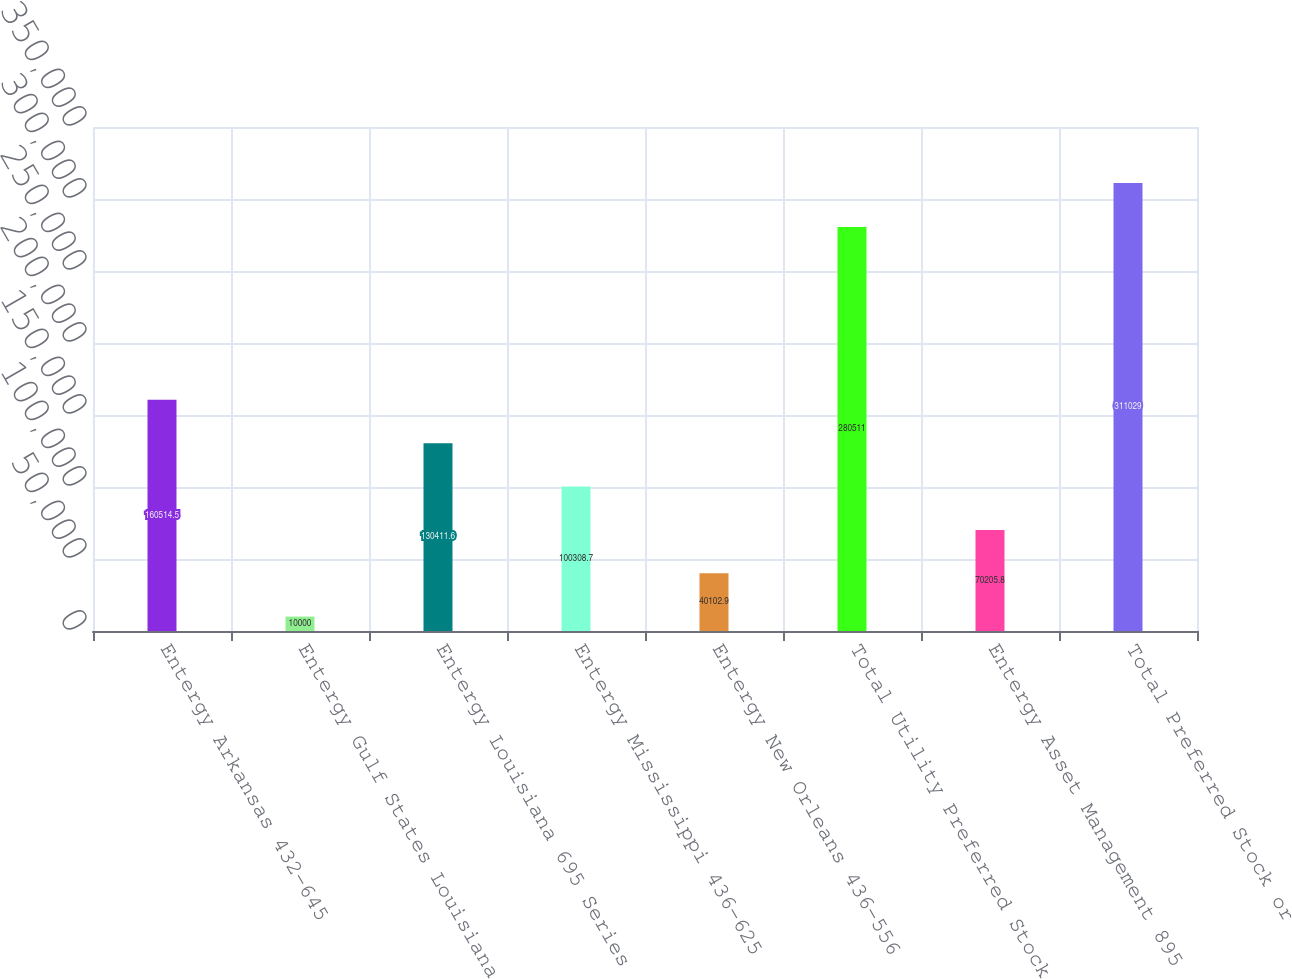Convert chart to OTSL. <chart><loc_0><loc_0><loc_500><loc_500><bar_chart><fcel>Entergy Arkansas 432-645<fcel>Entergy Gulf States Louisiana<fcel>Entergy Louisiana 695 Series<fcel>Entergy Mississippi 436-625<fcel>Entergy New Orleans 436-556<fcel>Total Utility Preferred Stock<fcel>Entergy Asset Management 895<fcel>Total Preferred Stock or<nl><fcel>160514<fcel>10000<fcel>130412<fcel>100309<fcel>40102.9<fcel>280511<fcel>70205.8<fcel>311029<nl></chart> 